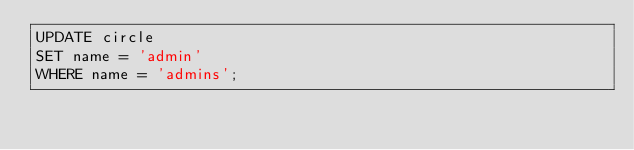<code> <loc_0><loc_0><loc_500><loc_500><_SQL_>UPDATE circle
SET name = 'admin'
WHERE name = 'admins';
</code> 